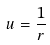<formula> <loc_0><loc_0><loc_500><loc_500>u = { \frac { 1 } { r } }</formula> 